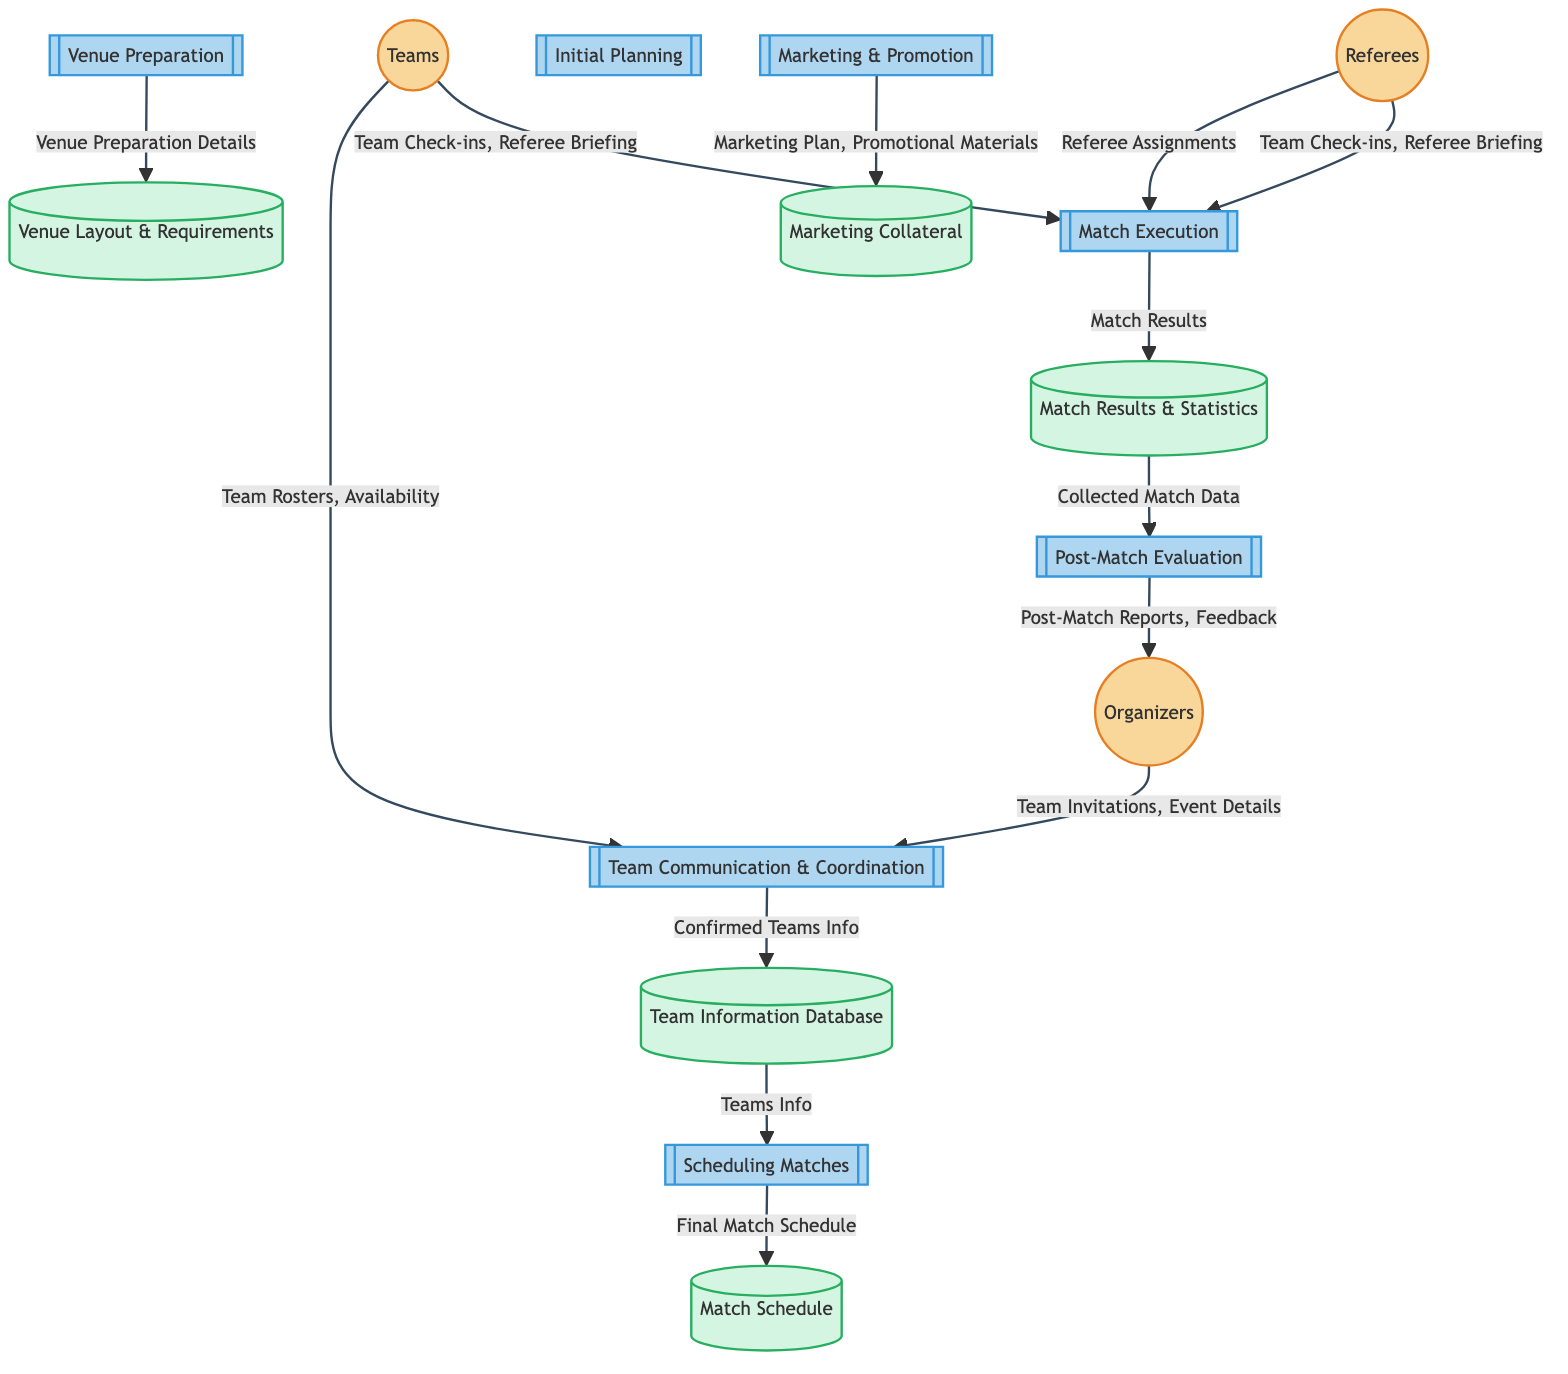What are the external entities involved in the diagram? The external entities in the diagram include Teams, Referees, and Organizers. Each represents a group that interacts with the processes illustrated.
Answer: Teams, Referees, Organizers How many processes are depicted in the diagram? The diagram includes seven distinct processes, labeled from P1 to P7, that outline various stages of organizing a basketball match.
Answer: 7 What information flows from Teams to Team Communication & Coordination? The information flowing from Teams to the process P2 is categorized as Team Rosters and Availability, providing necessary details for coordination.
Answer: Team Rosters, Availability Which data store receives the Final Match Schedule? The Final Match Schedule flows from the Scheduling Matches process (P3) to the Match Schedule data store (D2), indicating the documented schedule of the games.
Answer: Match Schedule Which entities provide input to the Match Execution process? Both Teams and Referees provide inputs to the Match Execution process (P6), specifically through Team Check-ins and Referee Briefing. This collaboration ensures smooth execution during matches.
Answer: Teams, Referees What is the output of the Match Execution process? The output from the Match Execution process (P6) is the Match Results, which are recorded in the Match Results & Statistics data store (D5). This flow captures the outcomes of the basketball games.
Answer: Match Results What is the final output sent to the Organizers? The final output sent to Organizers comes from the Post-Match Evaluation process (P7) and includes Post-Match Reports and Feedback, summarizing the event for further review.
Answer: Post-Match Reports, Feedback Which process is responsible for Venue Preparation Details? The Venue Preparation process (P4) is the one responsible for generating the Venue Preparation Details, which are captured in the Venue Layout & Requirements data store (D3).
Answer: Venue Preparation What direction does the data flow from the Team Information Database? The data flow from the Team Information Database (D1) directs towards the Scheduling Matches process (P3), providing essential Teams Info needed to organize the match schedule.
Answer: Towards Scheduling Matches 